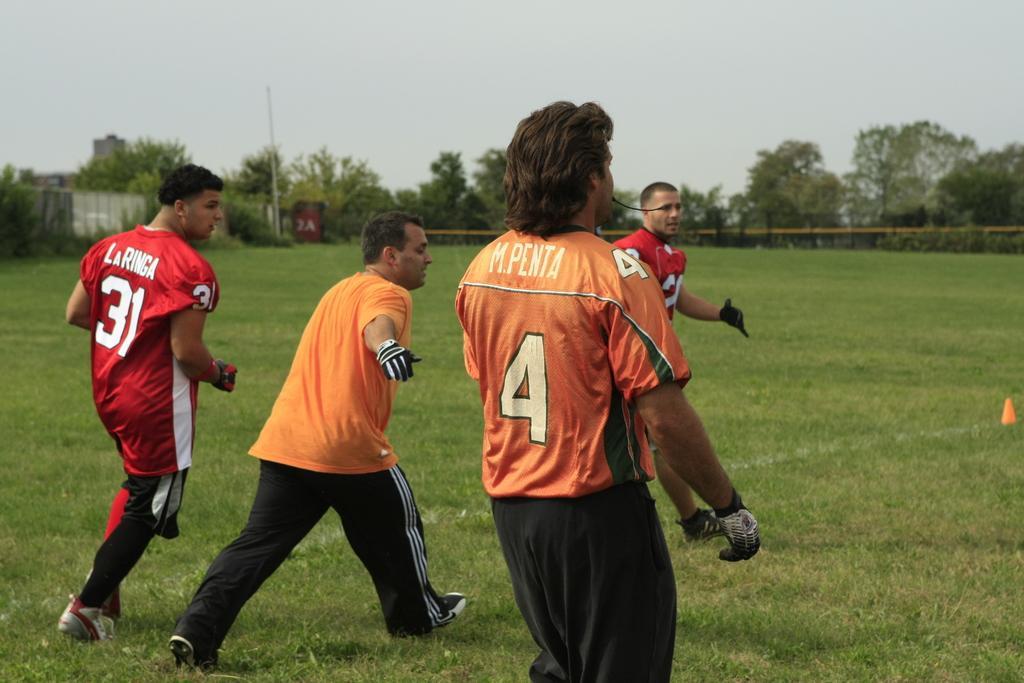In one or two sentences, can you explain what this image depicts? In this picture we can see some men wearing orange color shirt and black track, standing in the ground and playing. Behind there is a fencing railing and some trees. 